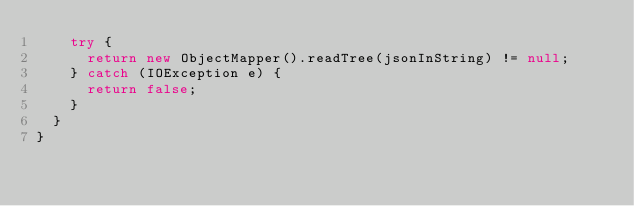<code> <loc_0><loc_0><loc_500><loc_500><_Java_>		try {
			return new ObjectMapper().readTree(jsonInString) != null;
		} catch (IOException e) {
			return false;
		}
	}
}
</code> 